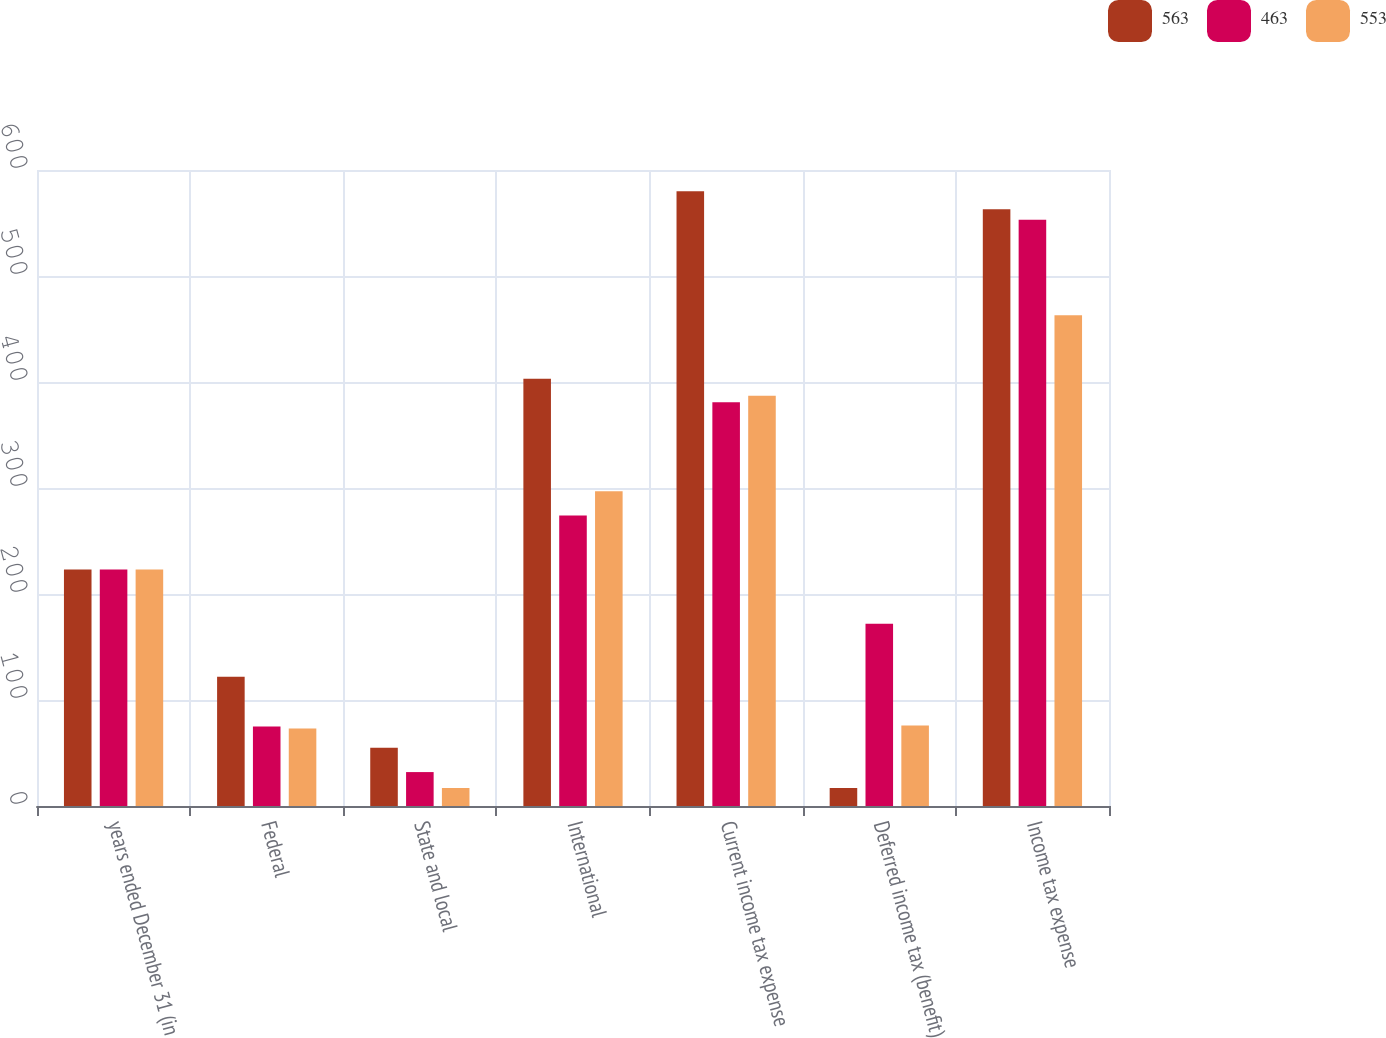Convert chart. <chart><loc_0><loc_0><loc_500><loc_500><stacked_bar_chart><ecel><fcel>years ended December 31 (in<fcel>Federal<fcel>State and local<fcel>International<fcel>Current income tax expense<fcel>Deferred income tax (benefit)<fcel>Income tax expense<nl><fcel>563<fcel>223<fcel>122<fcel>55<fcel>403<fcel>580<fcel>17<fcel>563<nl><fcel>463<fcel>223<fcel>75<fcel>32<fcel>274<fcel>381<fcel>172<fcel>553<nl><fcel>553<fcel>223<fcel>73<fcel>17<fcel>297<fcel>387<fcel>76<fcel>463<nl></chart> 